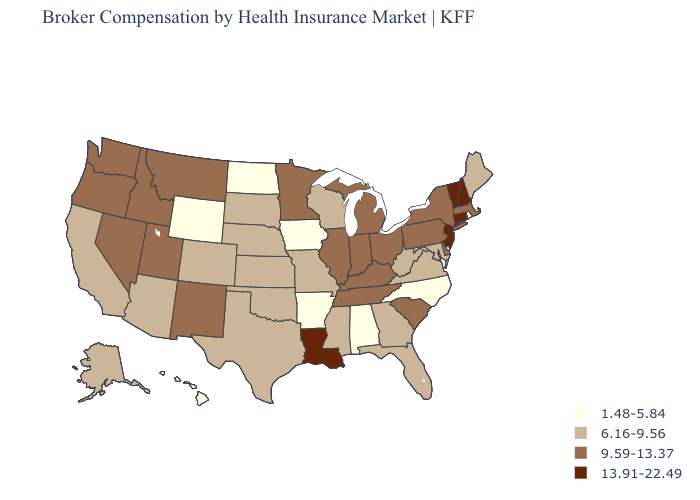What is the highest value in states that border Oregon?
Concise answer only. 9.59-13.37. What is the value of Hawaii?
Concise answer only. 1.48-5.84. Does Florida have a lower value than Arkansas?
Write a very short answer. No. What is the highest value in states that border Ohio?
Write a very short answer. 9.59-13.37. Does Iowa have the lowest value in the USA?
Short answer required. Yes. Name the states that have a value in the range 1.48-5.84?
Concise answer only. Alabama, Arkansas, Hawaii, Iowa, North Carolina, North Dakota, Rhode Island, Wyoming. Is the legend a continuous bar?
Quick response, please. No. Is the legend a continuous bar?
Keep it brief. No. Which states hav the highest value in the West?
Short answer required. Idaho, Montana, Nevada, New Mexico, Oregon, Utah, Washington. What is the value of North Dakota?
Answer briefly. 1.48-5.84. Does Tennessee have the same value as Montana?
Write a very short answer. Yes. Name the states that have a value in the range 13.91-22.49?
Keep it brief. Connecticut, Louisiana, New Hampshire, New Jersey, Vermont. Name the states that have a value in the range 9.59-13.37?
Give a very brief answer. Delaware, Idaho, Illinois, Indiana, Kentucky, Massachusetts, Michigan, Minnesota, Montana, Nevada, New Mexico, New York, Ohio, Oregon, Pennsylvania, South Carolina, Tennessee, Utah, Washington. How many symbols are there in the legend?
Answer briefly. 4. What is the value of Washington?
Concise answer only. 9.59-13.37. 